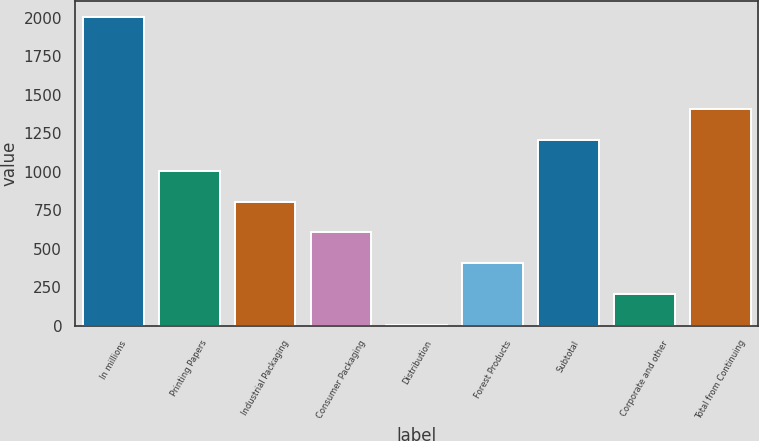Convert chart. <chart><loc_0><loc_0><loc_500><loc_500><bar_chart><fcel>In millions<fcel>Printing Papers<fcel>Industrial Packaging<fcel>Consumer Packaging<fcel>Distribution<fcel>Forest Products<fcel>Subtotal<fcel>Corporate and other<fcel>Total from Continuing<nl><fcel>2006<fcel>1006<fcel>806<fcel>606<fcel>6<fcel>406<fcel>1206<fcel>206<fcel>1406<nl></chart> 